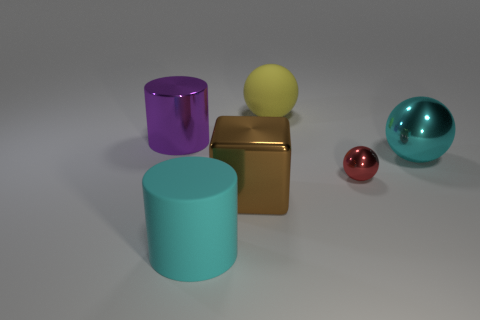Are there any red metallic objects in front of the large shiny thing that is in front of the big thing to the right of the yellow thing? No, there are no red metallic objects in front of the large shiny object. In the image, you can see a small red sphere, but it is positioned behind the large gold cube, not in front of it. 